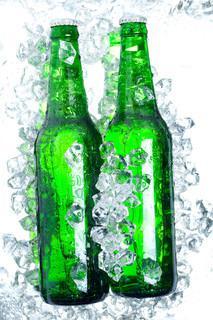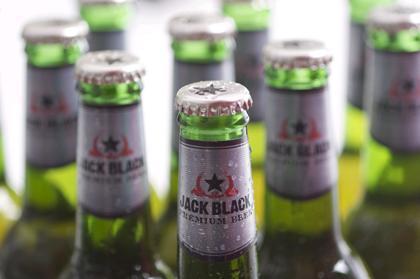The first image is the image on the left, the second image is the image on the right. Examine the images to the left and right. Is the description "Two green bottles are sitting near some ice." accurate? Answer yes or no. Yes. The first image is the image on the left, the second image is the image on the right. Examine the images to the left and right. Is the description "Neither individual image includes more than two bottles." accurate? Answer yes or no. No. 